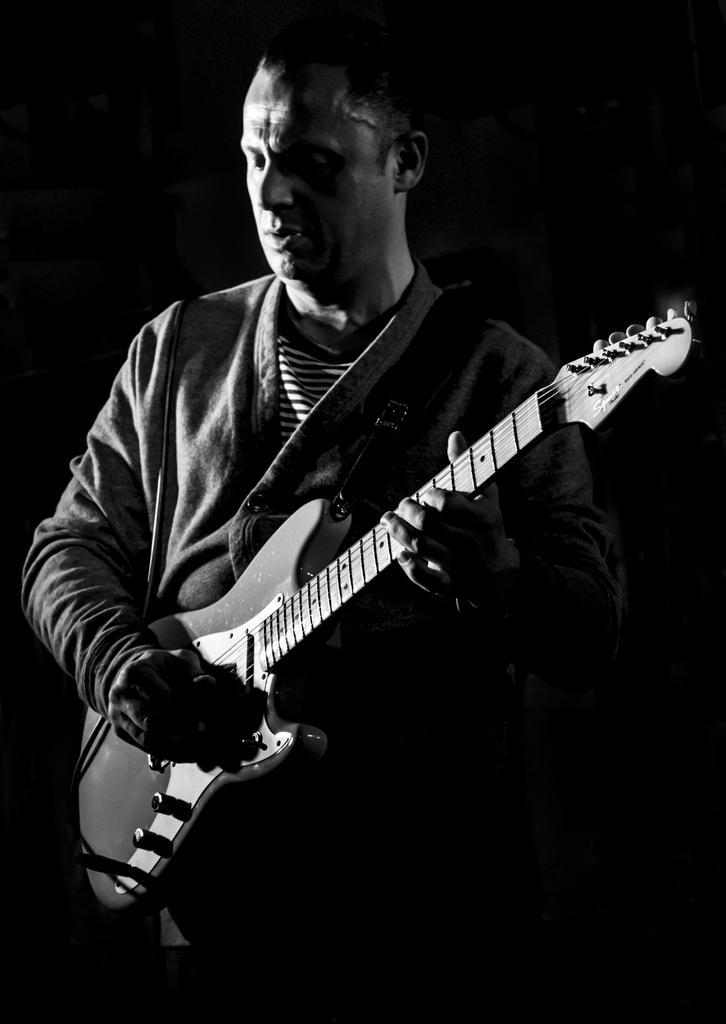Can you describe this image briefly? In this image a man is standing and holding a guitar in his hands. 